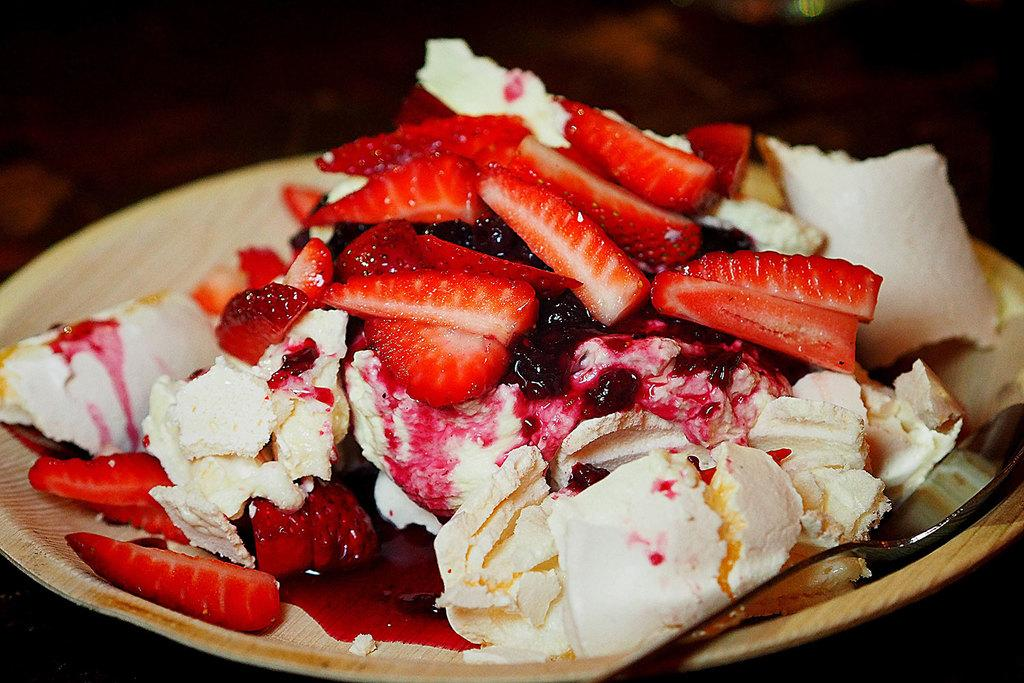What is on the plate that is visible in the image? There is food on a plate in the image. Can you describe the background of the image? The background of the image is blurry. What subject is the person teaching in the image? There is no person or teaching activity present in the image. How does the food on the plate move in the image? The food on the plate does not move in the image; it is stationary. 